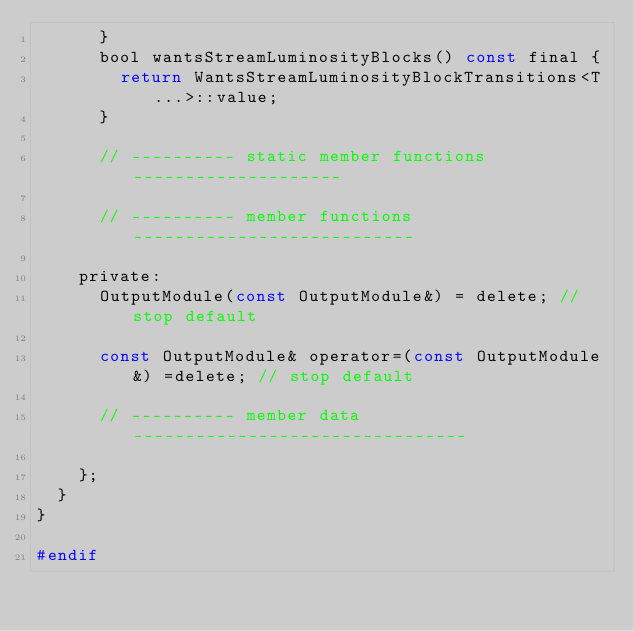<code> <loc_0><loc_0><loc_500><loc_500><_C_>      }
      bool wantsStreamLuminosityBlocks() const final {
        return WantsStreamLuminosityBlockTransitions<T...>::value;
      }
      
      // ---------- static member functions --------------------
      
      // ---------- member functions ---------------------------
      
    private:
      OutputModule(const OutputModule&) = delete; // stop default
      
      const OutputModule& operator=(const OutputModule&) =delete; // stop default
      
      // ---------- member data --------------------------------
      
    };
  }
}

#endif
</code> 